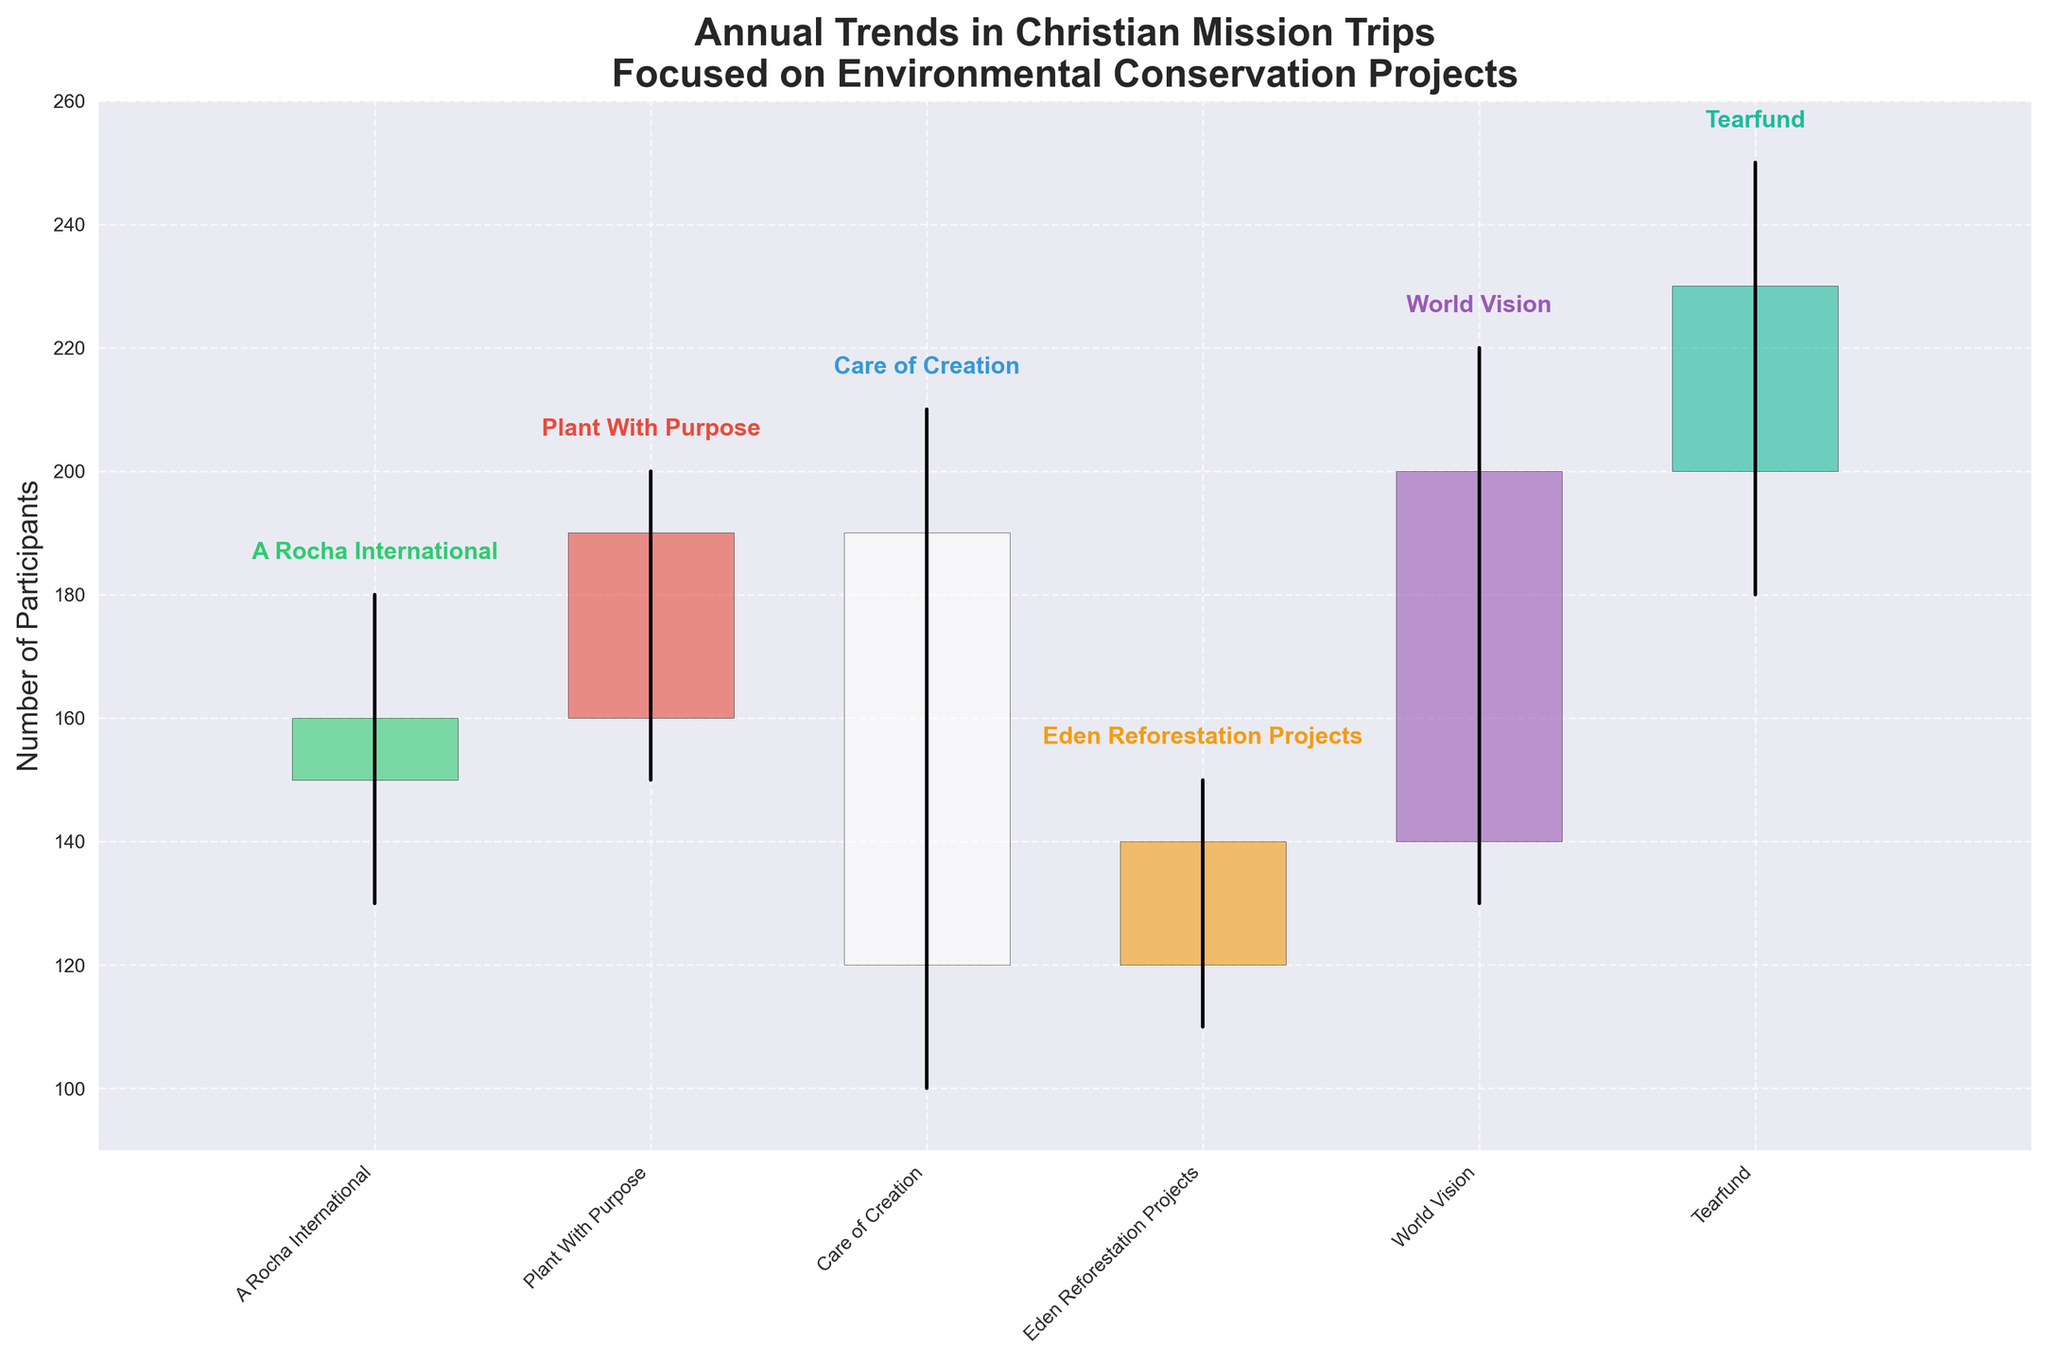What is the title of the chart? The title of the chart is displayed at the top. It reads "Annual Trends in Christian Mission Trips Focused on Environmental Conservation Projects".
Answer: Annual Trends in Christian Mission Trips Focused on Environmental Conservation Projects Which organization had the highest number of participants in 2023? Look for the bar labeled "Tearfund" and identify the 'High' value. The highest number of participants for 2023 is 250.
Answer: Tearfund How many organizations are represented in the chart? Count the number of distinct organization names along the x-axis. There are 6 different organizations.
Answer: 6 Between which years did Care of Creation experience its peak in participant number? Identify the 'High' value for Care of Creation and note its corresponding year, which is 2020.
Answer: 2020 How does the trend of World Vision's participant numbers in 2022 compare to its opening value? For World Vision in 2022, compare the 'High' value to the 'Open' value. The 'High' value (220) is higher than the 'Open' value (140).
Answer: Higher Which year saw the biggest drop in participants for any organization? Identify the year with the largest difference between 'High' and 'Low' values. Care of Creation in 2020 had the highest drop from 210 to 100.
Answer: 2020 Which organization saw the largest increase in participant numbers in a year? Compare the change from 'Open' to 'Close' values for each organization. Tearfund in 2023 increased from 200 to 230.
Answer: Tearfund What is the cumulative lowest point (sum of 'Low' values) recorded across these organizations? Sum the 'Low' values for each year: 130 + 150 + 100 + 110 + 130 + 180. The total is 800.
Answer: 800 What is the trend in participant numbers for Eden Reforestation Projects from 2021 to 2022? Compare 'Close' of 2021 for Eden Reforestation Projects with the 'Open' of World Vision in 2022. Eden Reforestation Projects closed at 140 in 2021, and World Vision opened at 140 in 2022, suggesting stability.
Answer: Stable 